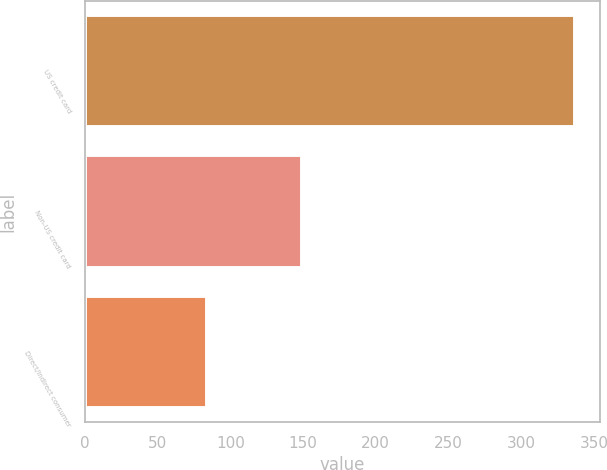<chart> <loc_0><loc_0><loc_500><loc_500><bar_chart><fcel>US credit card<fcel>Non-US credit card<fcel>Direct/Indirect consumer<nl><fcel>337<fcel>149<fcel>84<nl></chart> 